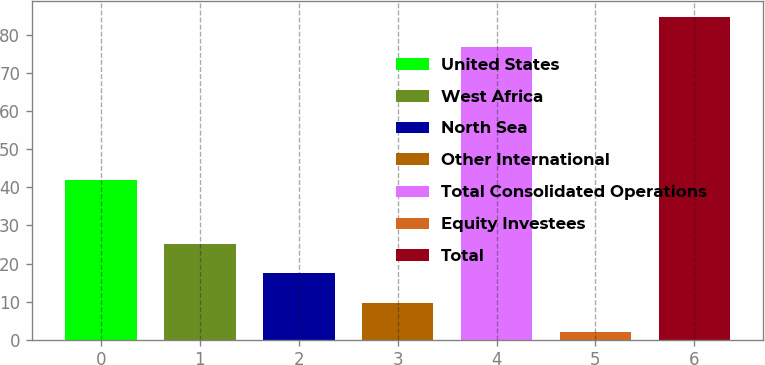Convert chart. <chart><loc_0><loc_0><loc_500><loc_500><bar_chart><fcel>United States<fcel>West Africa<fcel>North Sea<fcel>Other International<fcel>Total Consolidated Operations<fcel>Equity Investees<fcel>Total<nl><fcel>42<fcel>25.1<fcel>17.4<fcel>9.7<fcel>77<fcel>2<fcel>84.7<nl></chart> 